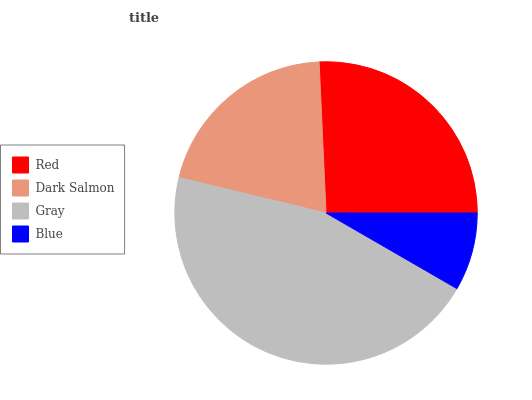Is Blue the minimum?
Answer yes or no. Yes. Is Gray the maximum?
Answer yes or no. Yes. Is Dark Salmon the minimum?
Answer yes or no. No. Is Dark Salmon the maximum?
Answer yes or no. No. Is Red greater than Dark Salmon?
Answer yes or no. Yes. Is Dark Salmon less than Red?
Answer yes or no. Yes. Is Dark Salmon greater than Red?
Answer yes or no. No. Is Red less than Dark Salmon?
Answer yes or no. No. Is Red the high median?
Answer yes or no. Yes. Is Dark Salmon the low median?
Answer yes or no. Yes. Is Blue the high median?
Answer yes or no. No. Is Gray the low median?
Answer yes or no. No. 